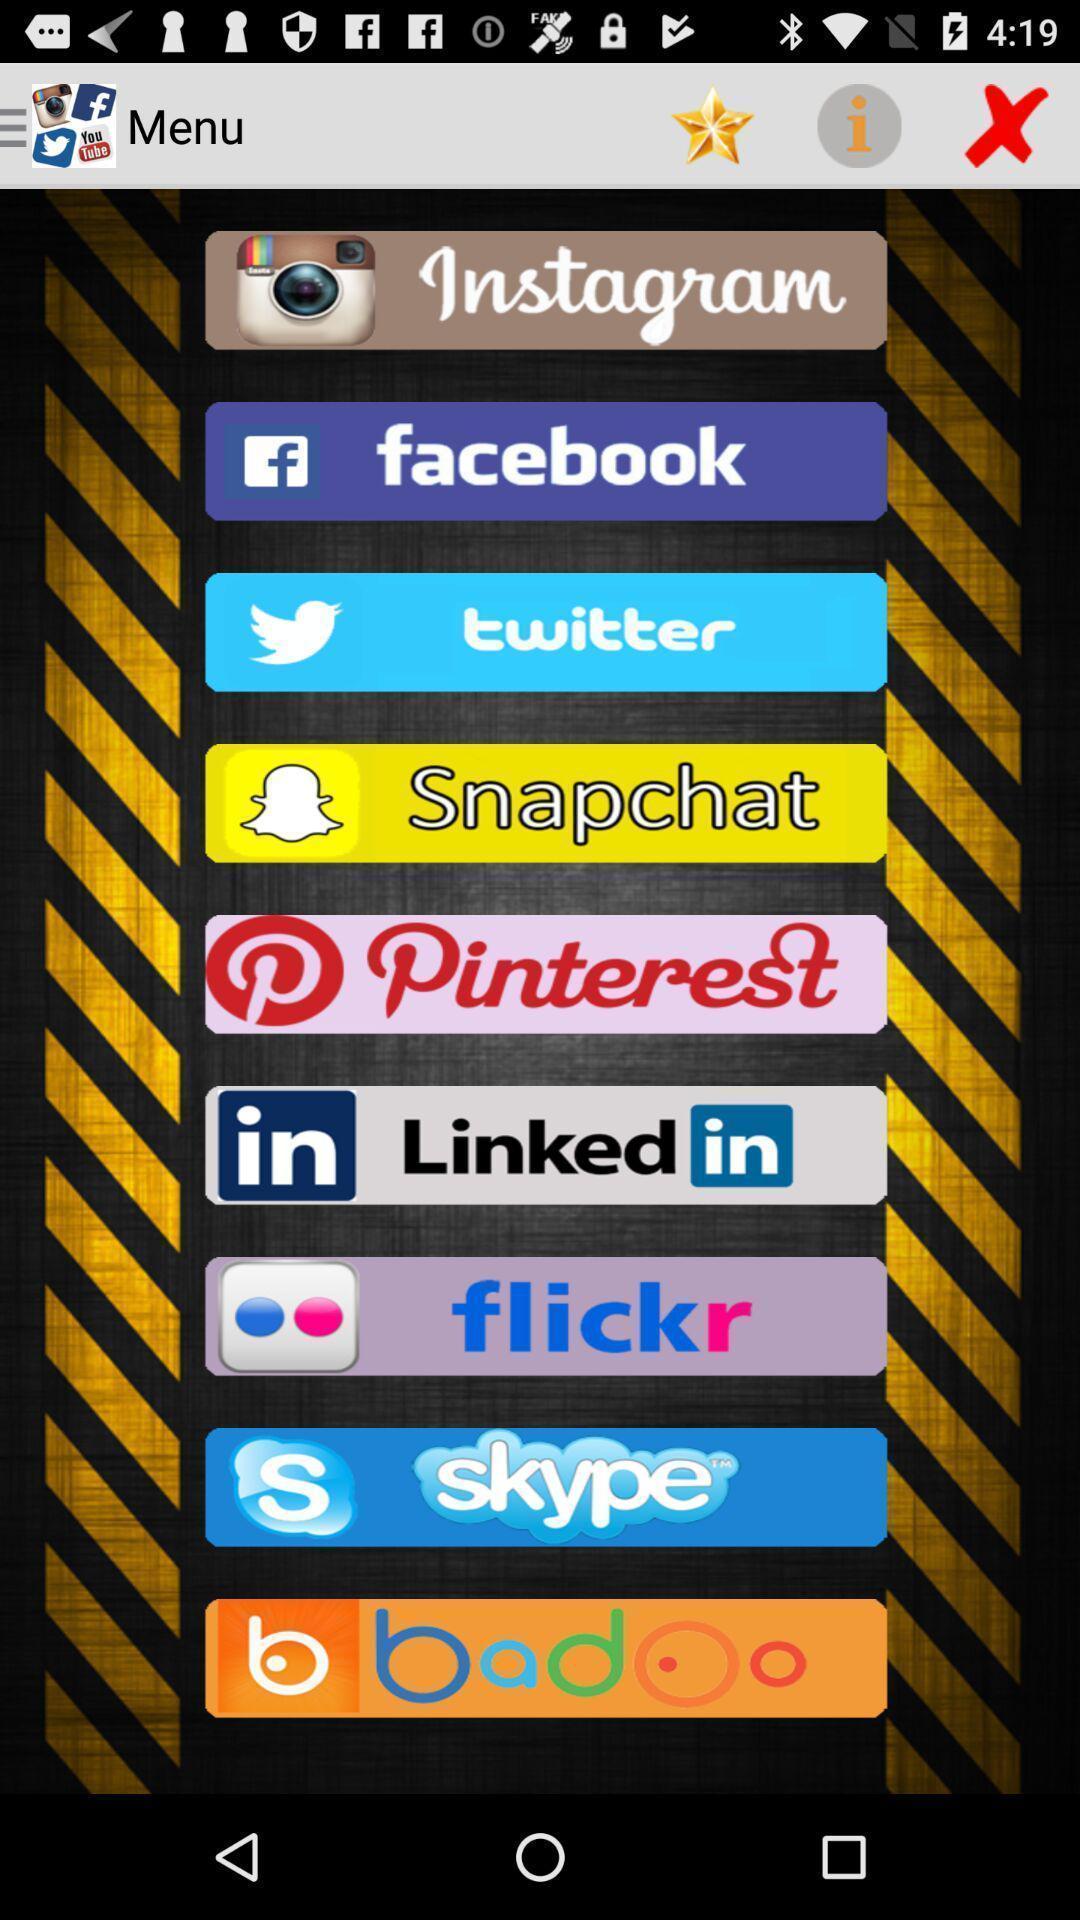What is the overall content of this screenshot? Set of options for applications on the screen. 